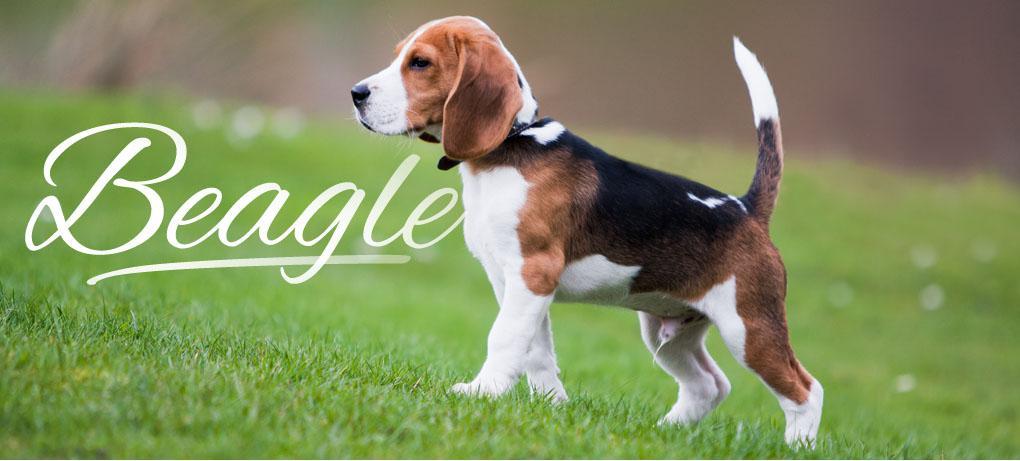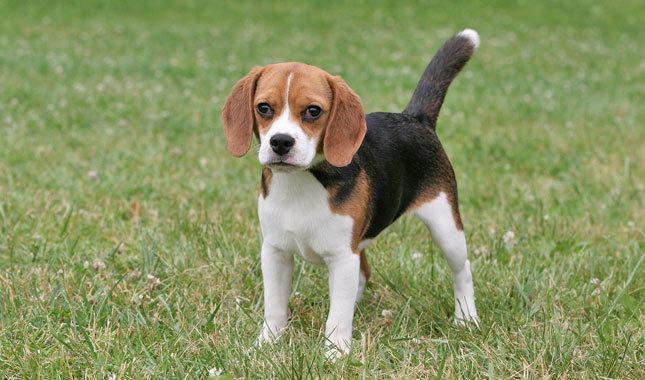The first image is the image on the left, the second image is the image on the right. For the images shown, is this caption "An image contains an animal that is not a floppy-eared beagle." true? Answer yes or no. No. 